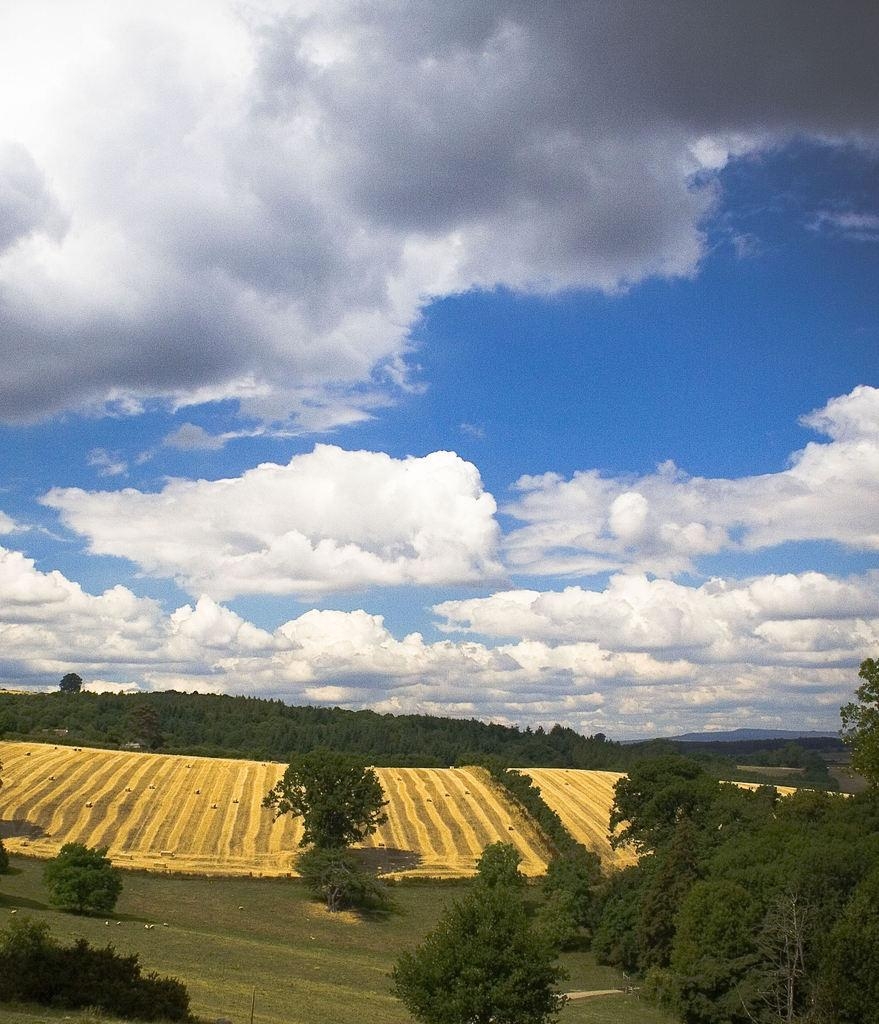What is the condition of the sky in the image? The sky in the image is cloudy. What can be found at the bottom of the image? There are trees, plants, and grass at the bottom of the image. What type of toys can be seen in the image? There are no toys present in the image. Can you recite a verse that is written on the grass in the image? There is no verse written on the grass in the image. 